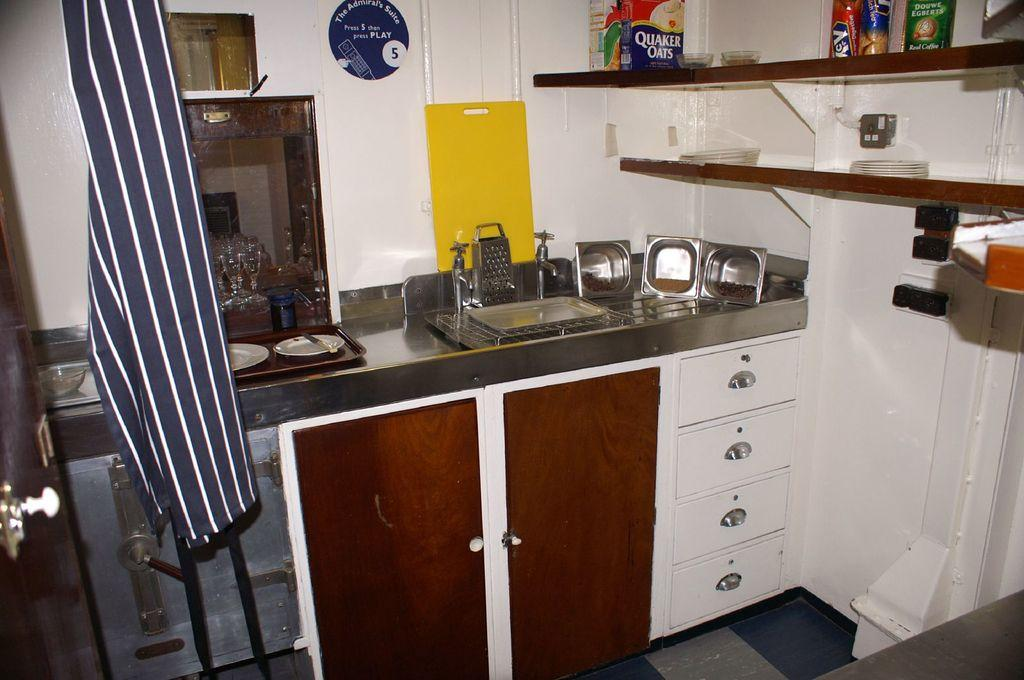<image>
Share a concise interpretation of the image provided. The blue sign tells users to Press 5 then press Play. 